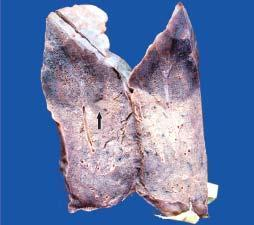how does the sectioned surface show dark tan firm areas?
Answer the question using a single word or phrase. With base on the pleura 